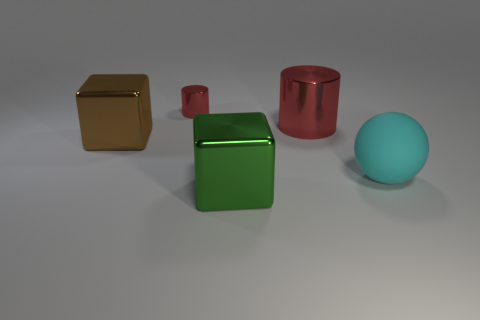Subtract all green cubes. How many cubes are left? 1 Subtract all cylinders. How many objects are left? 3 Add 5 big metallic objects. How many objects exist? 10 Subtract all big cyan cylinders. Subtract all tiny things. How many objects are left? 4 Add 4 red shiny cylinders. How many red shiny cylinders are left? 6 Add 1 small cylinders. How many small cylinders exist? 2 Subtract 0 green balls. How many objects are left? 5 Subtract all purple balls. Subtract all cyan cylinders. How many balls are left? 1 